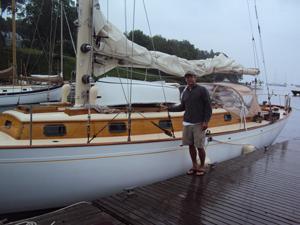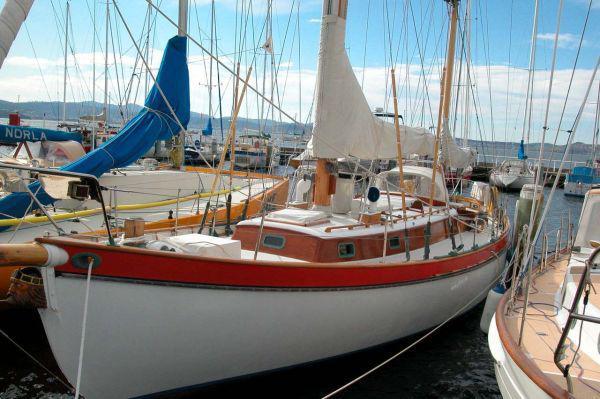The first image is the image on the left, the second image is the image on the right. Analyze the images presented: Is the assertion "A boat is tied up to a dock." valid? Answer yes or no. Yes. The first image is the image on the left, the second image is the image on the right. For the images displayed, is the sentence "The left and right image contains a total of two sailboats in the water." factually correct? Answer yes or no. No. 